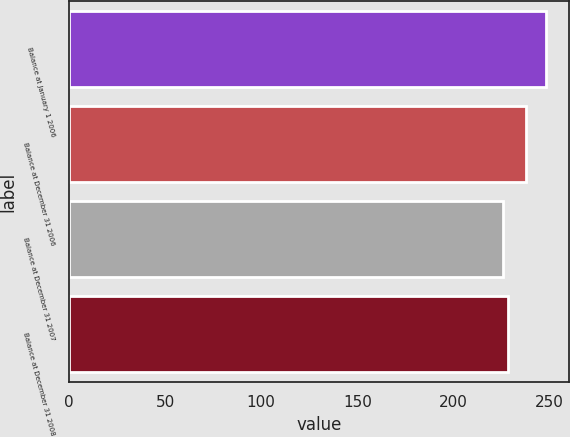Convert chart. <chart><loc_0><loc_0><loc_500><loc_500><bar_chart><fcel>Balance at January 1 2006<fcel>Balance at December 31 2006<fcel>Balance at December 31 2007<fcel>Balance at December 31 2008<nl><fcel>248<fcel>238<fcel>226<fcel>228.2<nl></chart> 